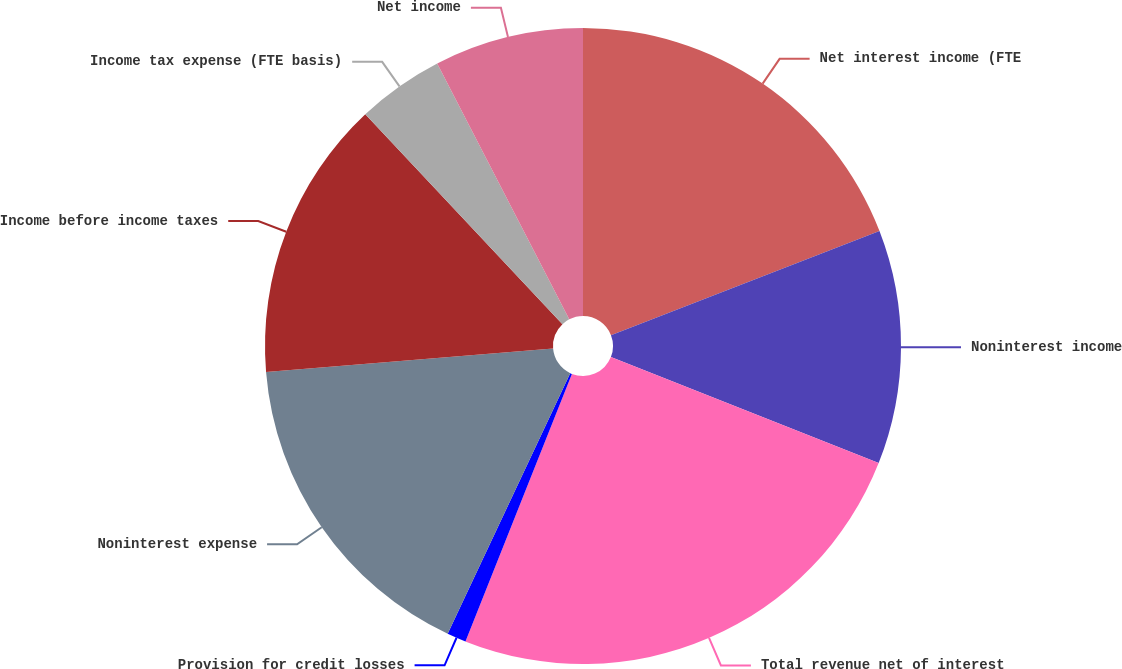Convert chart to OTSL. <chart><loc_0><loc_0><loc_500><loc_500><pie_chart><fcel>Net interest income (FTE<fcel>Noninterest income<fcel>Total revenue net of interest<fcel>Provision for credit losses<fcel>Noninterest expense<fcel>Income before income taxes<fcel>Income tax expense (FTE basis)<fcel>Net income<nl><fcel>19.11%<fcel>11.89%<fcel>25.02%<fcel>0.97%<fcel>16.7%<fcel>14.3%<fcel>4.42%<fcel>7.58%<nl></chart> 